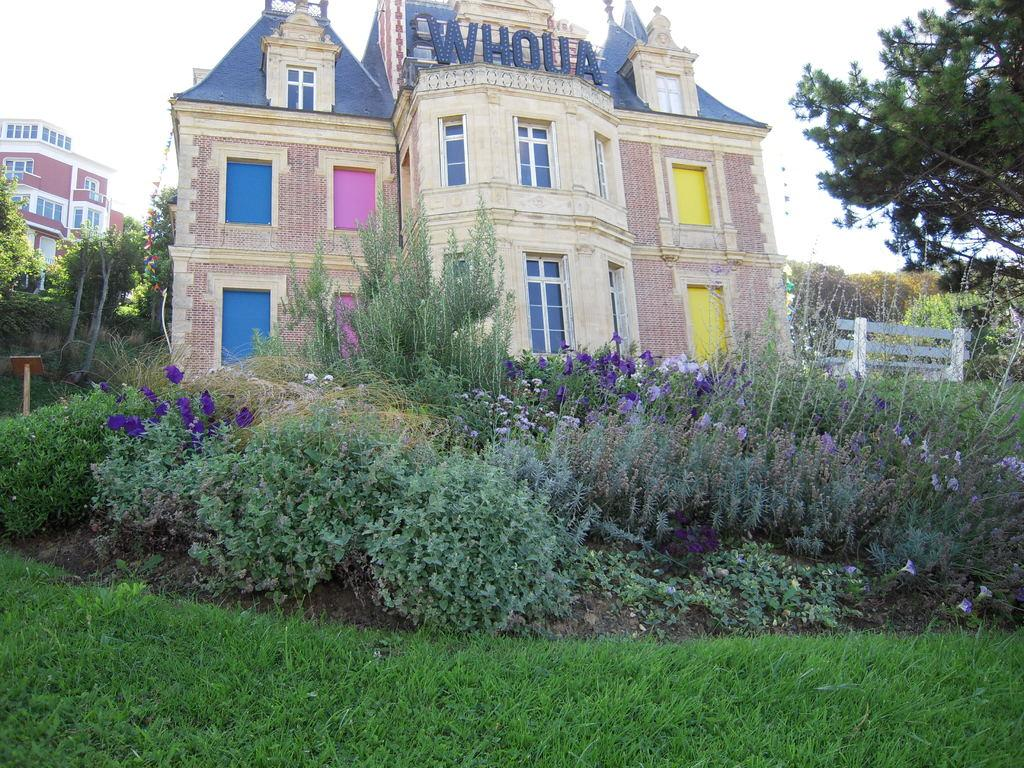What type of vegetation can be seen in the image? There is grass and plants in the image. What structures are visible in the background of the image? There are houses and trees in the background of the image. What is visible in the sky in the image? The sky is clear and visible in the background of the image. How many boats can be seen in the image? There are no boats present in the image. What type of animal is interacting with the plants in the image? There is no animal interacting with the plants in the image. 